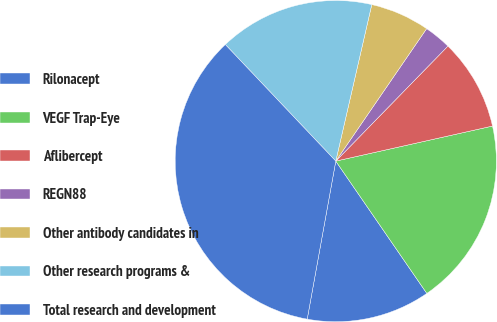Convert chart to OTSL. <chart><loc_0><loc_0><loc_500><loc_500><pie_chart><fcel>Rilonacept<fcel>VEGF Trap-Eye<fcel>Aflibercept<fcel>REGN88<fcel>Other antibody candidates in<fcel>Other research programs &<fcel>Total research and development<nl><fcel>12.44%<fcel>18.91%<fcel>9.2%<fcel>2.73%<fcel>5.97%<fcel>15.67%<fcel>35.08%<nl></chart> 